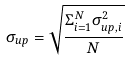<formula> <loc_0><loc_0><loc_500><loc_500>\sigma _ { u p } = \sqrt { \frac { \Sigma _ { i = 1 } ^ { N } \sigma ^ { 2 } _ { u p , i } } { N } }</formula> 